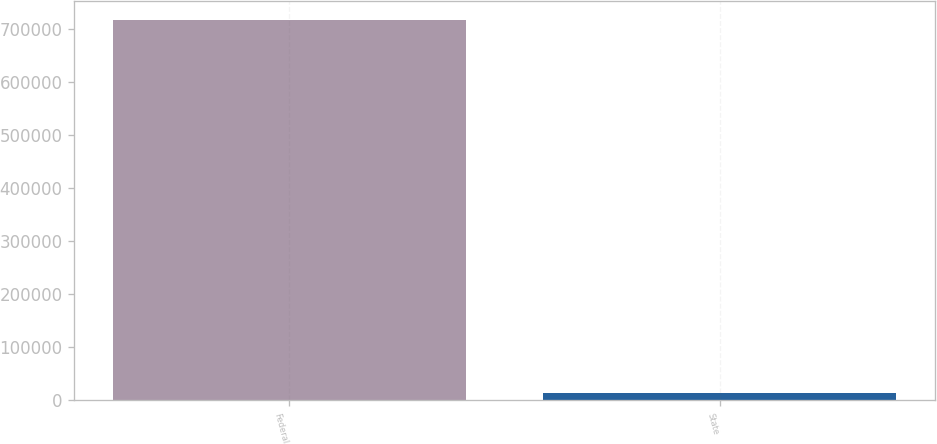Convert chart to OTSL. <chart><loc_0><loc_0><loc_500><loc_500><bar_chart><fcel>Federal<fcel>State<nl><fcel>715311<fcel>14128<nl></chart> 